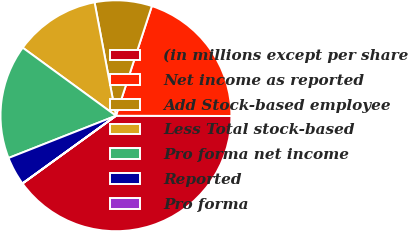<chart> <loc_0><loc_0><loc_500><loc_500><pie_chart><fcel>(in millions except per share<fcel>Net income as reported<fcel>Add Stock-based employee<fcel>Less Total stock-based<fcel>Pro forma net income<fcel>Reported<fcel>Pro forma<nl><fcel>39.99%<fcel>20.0%<fcel>8.0%<fcel>12.0%<fcel>16.0%<fcel>4.01%<fcel>0.01%<nl></chart> 